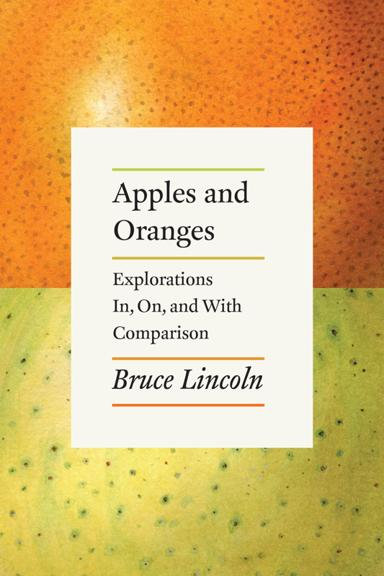What might be the significance of the choice of background color and texture on the book's cover? The background featuring a textured, gradient orange surface might be a visual metaphor representing the blending and contrasting of ideas, much like apples and oranges are distinct yet often compared. This clever design hint could be emphasizing the book's exploration of comparisons. 